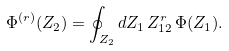<formula> <loc_0><loc_0><loc_500><loc_500>\Phi ^ { ( r ) } ( Z _ { 2 } ) = \oint _ { Z _ { 2 } } d Z _ { 1 } \, Z _ { 1 2 } ^ { r } \, \Phi ( Z _ { 1 } ) .</formula> 